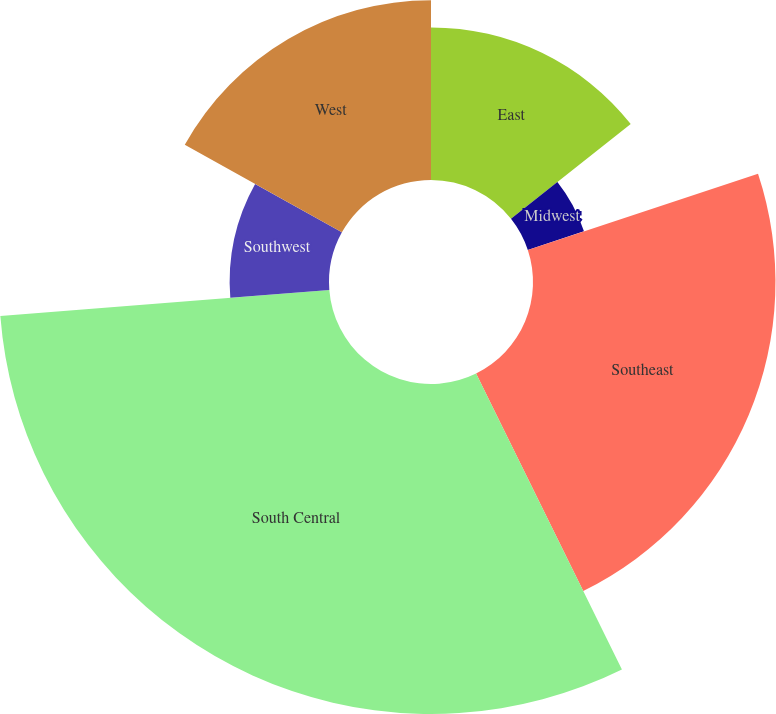Convert chart. <chart><loc_0><loc_0><loc_500><loc_500><pie_chart><fcel>East<fcel>Midwest<fcel>Southeast<fcel>South Central<fcel>Southwest<fcel>West<nl><fcel>14.35%<fcel>5.56%<fcel>22.8%<fcel>31.03%<fcel>9.34%<fcel>16.91%<nl></chart> 